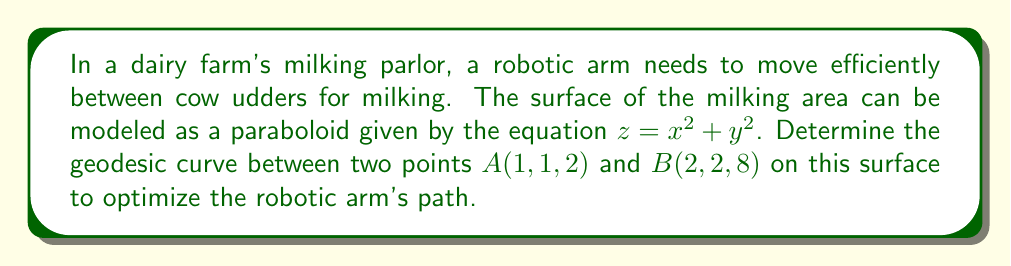What is the answer to this math problem? To find the geodesic curve between two points on a paraboloid, we'll follow these steps:

1) First, we need to express the surface in parametric form:
   $$x = u, y = v, z = u^2 + v^2$$

2) The metric tensor for this surface is:
   $$g_{ij} = \begin{pmatrix}
   1 + 4u^2 & 4uv \\
   4uv & 1 + 4v^2
   \end{pmatrix}$$

3) The geodesic equations are:
   $$\frac{d^2u}{dt^2} + \Gamma^u_{uu}\left(\frac{du}{dt}\right)^2 + 2\Gamma^u_{uv}\frac{du}{dt}\frac{dv}{dt} + \Gamma^u_{vv}\left(\frac{dv}{dt}\right)^2 = 0$$
   $$\frac{d^2v}{dt^2} + \Gamma^v_{uu}\left(\frac{du}{dt}\right)^2 + 2\Gamma^v_{uv}\frac{du}{dt}\frac{dv}{dt} + \Gamma^v_{vv}\left(\frac{dv}{dt}\right)^2 = 0$$

4) Calculating the Christoffel symbols:
   $$\Gamma^u_{uu} = \frac{2u}{1+4u^2}, \Gamma^u_{uv} = \Gamma^u_{vu} = -\frac{2v}{1+4u^2}, \Gamma^u_{vv} = 0$$
   $$\Gamma^v_{uu} = 0, \Gamma^v_{uv} = \Gamma^v_{vu} = -\frac{2u}{1+4v^2}, \Gamma^v_{vv} = \frac{2v}{1+4v^2}$$

5) Substituting these into the geodesic equations gives us a system of differential equations. However, solving this system analytically is extremely complex.

6) For practical purposes in precision agriculture, we can approximate the geodesic using a numerical method such as the Runge-Kutta method.

7) The initial conditions are:
   At $t=0$: $u(0) = 1, v(0) = 1$
   At $t=1$: $u(1) = 2, v(1) = 2$

8) Using a numerical solver, we can obtain a series of points that approximate the geodesic curve.

9) This curve represents the most efficient path for the robotic milking arm to move between the two specified udder positions, minimizing energy consumption and wear on the equipment.
Answer: The geodesic curve is a numerically approximated path on the paraboloid $z = x^2 + y^2$ from (1,1,2) to (2,2,8), obtained by solving the geodesic equations using initial conditions $u(0)=v(0)=1$, $u(1)=v(1)=2$. 